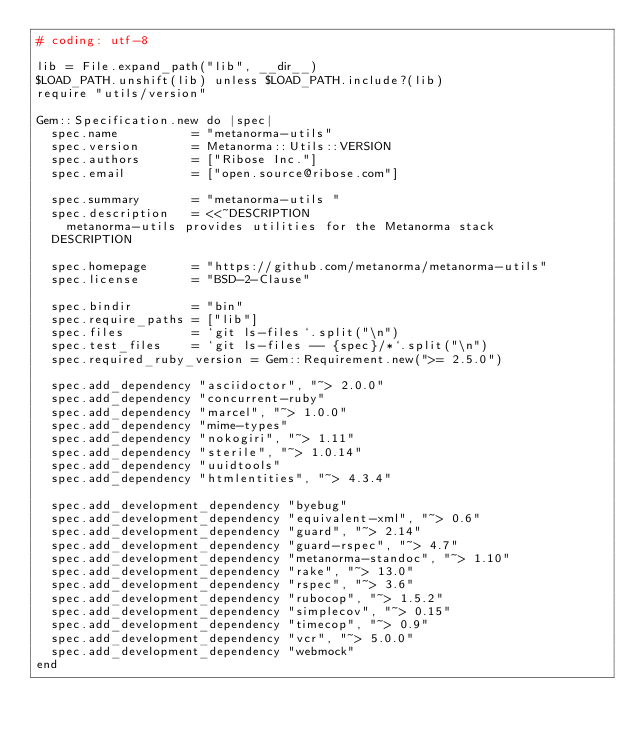<code> <loc_0><loc_0><loc_500><loc_500><_Ruby_># coding: utf-8

lib = File.expand_path("lib", __dir__)
$LOAD_PATH.unshift(lib) unless $LOAD_PATH.include?(lib)
require "utils/version"

Gem::Specification.new do |spec|
  spec.name          = "metanorma-utils"
  spec.version       = Metanorma::Utils::VERSION
  spec.authors       = ["Ribose Inc."]
  spec.email         = ["open.source@ribose.com"]

  spec.summary       = "metanorma-utils "
  spec.description   = <<~DESCRIPTION
    metanorma-utils provides utilities for the Metanorma stack
  DESCRIPTION

  spec.homepage      = "https://github.com/metanorma/metanorma-utils"
  spec.license       = "BSD-2-Clause"

  spec.bindir        = "bin"
  spec.require_paths = ["lib"]
  spec.files         = `git ls-files`.split("\n")
  spec.test_files    = `git ls-files -- {spec}/*`.split("\n")
  spec.required_ruby_version = Gem::Requirement.new(">= 2.5.0")

  spec.add_dependency "asciidoctor", "~> 2.0.0"
  spec.add_dependency "concurrent-ruby"
  spec.add_dependency "marcel", "~> 1.0.0"
  spec.add_dependency "mime-types"
  spec.add_dependency "nokogiri", "~> 1.11"
  spec.add_dependency "sterile", "~> 1.0.14"
  spec.add_dependency "uuidtools"
  spec.add_dependency "htmlentities", "~> 4.3.4"

  spec.add_development_dependency "byebug"
  spec.add_development_dependency "equivalent-xml", "~> 0.6"
  spec.add_development_dependency "guard", "~> 2.14"
  spec.add_development_dependency "guard-rspec", "~> 4.7"
  spec.add_development_dependency "metanorma-standoc", "~> 1.10"
  spec.add_development_dependency "rake", "~> 13.0"
  spec.add_development_dependency "rspec", "~> 3.6"
  spec.add_development_dependency "rubocop", "~> 1.5.2"
  spec.add_development_dependency "simplecov", "~> 0.15"
  spec.add_development_dependency "timecop", "~> 0.9"
  spec.add_development_dependency "vcr", "~> 5.0.0"
  spec.add_development_dependency "webmock"
end
</code> 